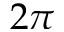Convert formula to latex. <formula><loc_0><loc_0><loc_500><loc_500>2 \pi</formula> 